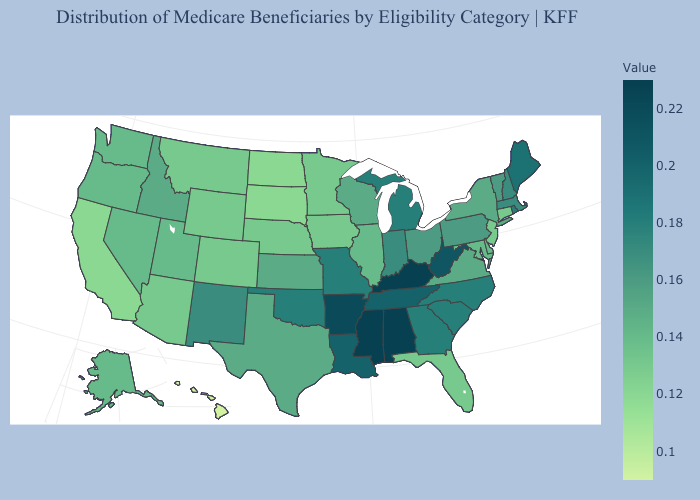Does Washington have a higher value than Massachusetts?
Give a very brief answer. No. Does the map have missing data?
Be succinct. No. Which states have the lowest value in the West?
Write a very short answer. Hawaii. Does Illinois have the highest value in the MidWest?
Concise answer only. No. Among the states that border Mississippi , does Tennessee have the lowest value?
Give a very brief answer. Yes. Which states hav the highest value in the Northeast?
Keep it brief. Maine. 